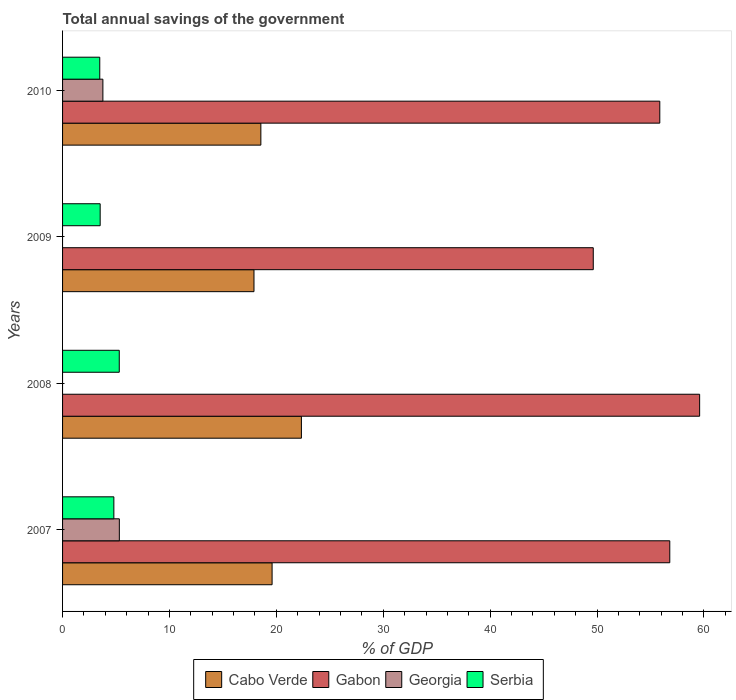How many different coloured bars are there?
Your answer should be very brief. 4. How many groups of bars are there?
Offer a terse response. 4. Are the number of bars on each tick of the Y-axis equal?
Your answer should be very brief. No. How many bars are there on the 1st tick from the top?
Make the answer very short. 4. What is the label of the 4th group of bars from the top?
Ensure brevity in your answer.  2007. What is the total annual savings of the government in Gabon in 2009?
Provide a succinct answer. 49.65. Across all years, what is the maximum total annual savings of the government in Cabo Verde?
Your response must be concise. 22.34. Across all years, what is the minimum total annual savings of the government in Georgia?
Make the answer very short. 0. In which year was the total annual savings of the government in Serbia maximum?
Give a very brief answer. 2008. What is the total total annual savings of the government in Cabo Verde in the graph?
Ensure brevity in your answer.  78.4. What is the difference between the total annual savings of the government in Cabo Verde in 2007 and that in 2008?
Give a very brief answer. -2.74. What is the difference between the total annual savings of the government in Cabo Verde in 2010 and the total annual savings of the government in Gabon in 2009?
Ensure brevity in your answer.  -31.1. What is the average total annual savings of the government in Gabon per year?
Offer a very short reply. 55.48. In the year 2009, what is the difference between the total annual savings of the government in Gabon and total annual savings of the government in Serbia?
Offer a terse response. 46.13. In how many years, is the total annual savings of the government in Georgia greater than 34 %?
Make the answer very short. 0. What is the ratio of the total annual savings of the government in Serbia in 2007 to that in 2008?
Ensure brevity in your answer.  0.9. What is the difference between the highest and the second highest total annual savings of the government in Cabo Verde?
Make the answer very short. 2.74. What is the difference between the highest and the lowest total annual savings of the government in Cabo Verde?
Keep it short and to the point. 4.44. Is the sum of the total annual savings of the government in Serbia in 2007 and 2008 greater than the maximum total annual savings of the government in Georgia across all years?
Provide a short and direct response. Yes. How many years are there in the graph?
Offer a terse response. 4. What is the difference between two consecutive major ticks on the X-axis?
Your answer should be compact. 10. Are the values on the major ticks of X-axis written in scientific E-notation?
Provide a succinct answer. No. Does the graph contain any zero values?
Keep it short and to the point. Yes. Does the graph contain grids?
Make the answer very short. No. What is the title of the graph?
Provide a short and direct response. Total annual savings of the government. Does "Haiti" appear as one of the legend labels in the graph?
Provide a short and direct response. No. What is the label or title of the X-axis?
Your answer should be very brief. % of GDP. What is the label or title of the Y-axis?
Give a very brief answer. Years. What is the % of GDP in Cabo Verde in 2007?
Your answer should be compact. 19.6. What is the % of GDP in Gabon in 2007?
Provide a short and direct response. 56.8. What is the % of GDP of Georgia in 2007?
Provide a succinct answer. 5.31. What is the % of GDP of Serbia in 2007?
Your answer should be compact. 4.8. What is the % of GDP of Cabo Verde in 2008?
Offer a very short reply. 22.34. What is the % of GDP in Gabon in 2008?
Ensure brevity in your answer.  59.6. What is the % of GDP of Serbia in 2008?
Your response must be concise. 5.3. What is the % of GDP of Cabo Verde in 2009?
Your answer should be very brief. 17.91. What is the % of GDP of Gabon in 2009?
Your response must be concise. 49.65. What is the % of GDP of Georgia in 2009?
Ensure brevity in your answer.  0. What is the % of GDP of Serbia in 2009?
Provide a short and direct response. 3.52. What is the % of GDP in Cabo Verde in 2010?
Your answer should be compact. 18.55. What is the % of GDP of Gabon in 2010?
Give a very brief answer. 55.87. What is the % of GDP of Georgia in 2010?
Offer a terse response. 3.77. What is the % of GDP in Serbia in 2010?
Give a very brief answer. 3.48. Across all years, what is the maximum % of GDP in Cabo Verde?
Your answer should be very brief. 22.34. Across all years, what is the maximum % of GDP in Gabon?
Give a very brief answer. 59.6. Across all years, what is the maximum % of GDP in Georgia?
Keep it short and to the point. 5.31. Across all years, what is the maximum % of GDP in Serbia?
Offer a terse response. 5.3. Across all years, what is the minimum % of GDP of Cabo Verde?
Provide a succinct answer. 17.91. Across all years, what is the minimum % of GDP in Gabon?
Provide a succinct answer. 49.65. Across all years, what is the minimum % of GDP of Georgia?
Provide a succinct answer. 0. Across all years, what is the minimum % of GDP of Serbia?
Offer a very short reply. 3.48. What is the total % of GDP of Cabo Verde in the graph?
Give a very brief answer. 78.4. What is the total % of GDP of Gabon in the graph?
Your response must be concise. 221.92. What is the total % of GDP of Georgia in the graph?
Your response must be concise. 9.08. What is the total % of GDP in Serbia in the graph?
Offer a terse response. 17.1. What is the difference between the % of GDP in Cabo Verde in 2007 and that in 2008?
Keep it short and to the point. -2.74. What is the difference between the % of GDP in Gabon in 2007 and that in 2008?
Make the answer very short. -2.79. What is the difference between the % of GDP in Serbia in 2007 and that in 2008?
Offer a very short reply. -0.5. What is the difference between the % of GDP of Cabo Verde in 2007 and that in 2009?
Your response must be concise. 1.69. What is the difference between the % of GDP of Gabon in 2007 and that in 2009?
Provide a short and direct response. 7.16. What is the difference between the % of GDP in Serbia in 2007 and that in 2009?
Ensure brevity in your answer.  1.28. What is the difference between the % of GDP of Cabo Verde in 2007 and that in 2010?
Give a very brief answer. 1.05. What is the difference between the % of GDP in Gabon in 2007 and that in 2010?
Provide a short and direct response. 0.93. What is the difference between the % of GDP in Georgia in 2007 and that in 2010?
Your answer should be very brief. 1.54. What is the difference between the % of GDP in Serbia in 2007 and that in 2010?
Your answer should be compact. 1.32. What is the difference between the % of GDP of Cabo Verde in 2008 and that in 2009?
Offer a terse response. 4.44. What is the difference between the % of GDP in Gabon in 2008 and that in 2009?
Make the answer very short. 9.95. What is the difference between the % of GDP in Serbia in 2008 and that in 2009?
Offer a very short reply. 1.79. What is the difference between the % of GDP in Cabo Verde in 2008 and that in 2010?
Your response must be concise. 3.79. What is the difference between the % of GDP in Gabon in 2008 and that in 2010?
Your response must be concise. 3.73. What is the difference between the % of GDP of Serbia in 2008 and that in 2010?
Your answer should be very brief. 1.82. What is the difference between the % of GDP of Cabo Verde in 2009 and that in 2010?
Offer a very short reply. -0.64. What is the difference between the % of GDP of Gabon in 2009 and that in 2010?
Offer a terse response. -6.22. What is the difference between the % of GDP of Serbia in 2009 and that in 2010?
Give a very brief answer. 0.04. What is the difference between the % of GDP in Cabo Verde in 2007 and the % of GDP in Gabon in 2008?
Your answer should be compact. -40. What is the difference between the % of GDP in Cabo Verde in 2007 and the % of GDP in Serbia in 2008?
Your answer should be compact. 14.3. What is the difference between the % of GDP in Gabon in 2007 and the % of GDP in Serbia in 2008?
Your answer should be very brief. 51.5. What is the difference between the % of GDP of Georgia in 2007 and the % of GDP of Serbia in 2008?
Make the answer very short. 0.01. What is the difference between the % of GDP of Cabo Verde in 2007 and the % of GDP of Gabon in 2009?
Keep it short and to the point. -30.05. What is the difference between the % of GDP of Cabo Verde in 2007 and the % of GDP of Serbia in 2009?
Offer a very short reply. 16.08. What is the difference between the % of GDP of Gabon in 2007 and the % of GDP of Serbia in 2009?
Your answer should be very brief. 53.29. What is the difference between the % of GDP in Georgia in 2007 and the % of GDP in Serbia in 2009?
Make the answer very short. 1.79. What is the difference between the % of GDP in Cabo Verde in 2007 and the % of GDP in Gabon in 2010?
Your answer should be very brief. -36.27. What is the difference between the % of GDP of Cabo Verde in 2007 and the % of GDP of Georgia in 2010?
Make the answer very short. 15.83. What is the difference between the % of GDP of Cabo Verde in 2007 and the % of GDP of Serbia in 2010?
Offer a very short reply. 16.12. What is the difference between the % of GDP in Gabon in 2007 and the % of GDP in Georgia in 2010?
Your response must be concise. 53.03. What is the difference between the % of GDP in Gabon in 2007 and the % of GDP in Serbia in 2010?
Make the answer very short. 53.32. What is the difference between the % of GDP in Georgia in 2007 and the % of GDP in Serbia in 2010?
Your answer should be compact. 1.83. What is the difference between the % of GDP of Cabo Verde in 2008 and the % of GDP of Gabon in 2009?
Make the answer very short. -27.3. What is the difference between the % of GDP in Cabo Verde in 2008 and the % of GDP in Serbia in 2009?
Provide a short and direct response. 18.83. What is the difference between the % of GDP in Gabon in 2008 and the % of GDP in Serbia in 2009?
Provide a short and direct response. 56.08. What is the difference between the % of GDP of Cabo Verde in 2008 and the % of GDP of Gabon in 2010?
Offer a terse response. -33.53. What is the difference between the % of GDP of Cabo Verde in 2008 and the % of GDP of Georgia in 2010?
Provide a succinct answer. 18.57. What is the difference between the % of GDP of Cabo Verde in 2008 and the % of GDP of Serbia in 2010?
Keep it short and to the point. 18.86. What is the difference between the % of GDP in Gabon in 2008 and the % of GDP in Georgia in 2010?
Ensure brevity in your answer.  55.82. What is the difference between the % of GDP in Gabon in 2008 and the % of GDP in Serbia in 2010?
Ensure brevity in your answer.  56.12. What is the difference between the % of GDP in Cabo Verde in 2009 and the % of GDP in Gabon in 2010?
Your answer should be very brief. -37.96. What is the difference between the % of GDP of Cabo Verde in 2009 and the % of GDP of Georgia in 2010?
Offer a terse response. 14.13. What is the difference between the % of GDP of Cabo Verde in 2009 and the % of GDP of Serbia in 2010?
Provide a short and direct response. 14.43. What is the difference between the % of GDP of Gabon in 2009 and the % of GDP of Georgia in 2010?
Keep it short and to the point. 45.87. What is the difference between the % of GDP of Gabon in 2009 and the % of GDP of Serbia in 2010?
Provide a short and direct response. 46.17. What is the average % of GDP in Cabo Verde per year?
Make the answer very short. 19.6. What is the average % of GDP in Gabon per year?
Your response must be concise. 55.48. What is the average % of GDP of Georgia per year?
Offer a terse response. 2.27. What is the average % of GDP of Serbia per year?
Offer a terse response. 4.28. In the year 2007, what is the difference between the % of GDP of Cabo Verde and % of GDP of Gabon?
Make the answer very short. -37.2. In the year 2007, what is the difference between the % of GDP in Cabo Verde and % of GDP in Georgia?
Keep it short and to the point. 14.29. In the year 2007, what is the difference between the % of GDP in Cabo Verde and % of GDP in Serbia?
Keep it short and to the point. 14.8. In the year 2007, what is the difference between the % of GDP in Gabon and % of GDP in Georgia?
Keep it short and to the point. 51.49. In the year 2007, what is the difference between the % of GDP in Gabon and % of GDP in Serbia?
Provide a succinct answer. 52. In the year 2007, what is the difference between the % of GDP in Georgia and % of GDP in Serbia?
Offer a very short reply. 0.51. In the year 2008, what is the difference between the % of GDP in Cabo Verde and % of GDP in Gabon?
Ensure brevity in your answer.  -37.25. In the year 2008, what is the difference between the % of GDP in Cabo Verde and % of GDP in Serbia?
Keep it short and to the point. 17.04. In the year 2008, what is the difference between the % of GDP in Gabon and % of GDP in Serbia?
Keep it short and to the point. 54.29. In the year 2009, what is the difference between the % of GDP in Cabo Verde and % of GDP in Gabon?
Offer a terse response. -31.74. In the year 2009, what is the difference between the % of GDP in Cabo Verde and % of GDP in Serbia?
Make the answer very short. 14.39. In the year 2009, what is the difference between the % of GDP in Gabon and % of GDP in Serbia?
Give a very brief answer. 46.13. In the year 2010, what is the difference between the % of GDP in Cabo Verde and % of GDP in Gabon?
Give a very brief answer. -37.32. In the year 2010, what is the difference between the % of GDP of Cabo Verde and % of GDP of Georgia?
Offer a very short reply. 14.78. In the year 2010, what is the difference between the % of GDP of Cabo Verde and % of GDP of Serbia?
Ensure brevity in your answer.  15.07. In the year 2010, what is the difference between the % of GDP of Gabon and % of GDP of Georgia?
Give a very brief answer. 52.1. In the year 2010, what is the difference between the % of GDP in Gabon and % of GDP in Serbia?
Ensure brevity in your answer.  52.39. In the year 2010, what is the difference between the % of GDP of Georgia and % of GDP of Serbia?
Ensure brevity in your answer.  0.29. What is the ratio of the % of GDP of Cabo Verde in 2007 to that in 2008?
Offer a terse response. 0.88. What is the ratio of the % of GDP of Gabon in 2007 to that in 2008?
Your answer should be compact. 0.95. What is the ratio of the % of GDP of Serbia in 2007 to that in 2008?
Make the answer very short. 0.9. What is the ratio of the % of GDP in Cabo Verde in 2007 to that in 2009?
Your response must be concise. 1.09. What is the ratio of the % of GDP of Gabon in 2007 to that in 2009?
Keep it short and to the point. 1.14. What is the ratio of the % of GDP of Serbia in 2007 to that in 2009?
Provide a succinct answer. 1.36. What is the ratio of the % of GDP of Cabo Verde in 2007 to that in 2010?
Keep it short and to the point. 1.06. What is the ratio of the % of GDP in Gabon in 2007 to that in 2010?
Keep it short and to the point. 1.02. What is the ratio of the % of GDP of Georgia in 2007 to that in 2010?
Your response must be concise. 1.41. What is the ratio of the % of GDP in Serbia in 2007 to that in 2010?
Ensure brevity in your answer.  1.38. What is the ratio of the % of GDP of Cabo Verde in 2008 to that in 2009?
Offer a very short reply. 1.25. What is the ratio of the % of GDP in Gabon in 2008 to that in 2009?
Make the answer very short. 1.2. What is the ratio of the % of GDP in Serbia in 2008 to that in 2009?
Offer a terse response. 1.51. What is the ratio of the % of GDP of Cabo Verde in 2008 to that in 2010?
Your response must be concise. 1.2. What is the ratio of the % of GDP of Gabon in 2008 to that in 2010?
Your answer should be compact. 1.07. What is the ratio of the % of GDP of Serbia in 2008 to that in 2010?
Offer a very short reply. 1.52. What is the ratio of the % of GDP of Cabo Verde in 2009 to that in 2010?
Offer a terse response. 0.97. What is the ratio of the % of GDP in Gabon in 2009 to that in 2010?
Keep it short and to the point. 0.89. What is the ratio of the % of GDP of Serbia in 2009 to that in 2010?
Provide a succinct answer. 1.01. What is the difference between the highest and the second highest % of GDP in Cabo Verde?
Offer a terse response. 2.74. What is the difference between the highest and the second highest % of GDP in Gabon?
Offer a very short reply. 2.79. What is the difference between the highest and the second highest % of GDP in Serbia?
Make the answer very short. 0.5. What is the difference between the highest and the lowest % of GDP of Cabo Verde?
Keep it short and to the point. 4.44. What is the difference between the highest and the lowest % of GDP in Gabon?
Provide a short and direct response. 9.95. What is the difference between the highest and the lowest % of GDP in Georgia?
Provide a succinct answer. 5.31. What is the difference between the highest and the lowest % of GDP in Serbia?
Keep it short and to the point. 1.82. 